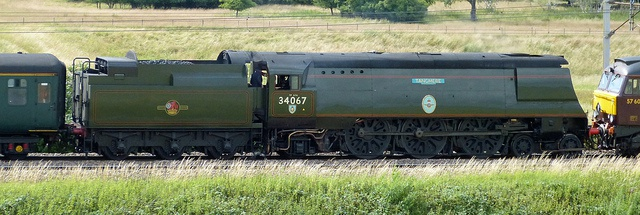Describe the objects in this image and their specific colors. I can see a train in tan, black, gray, purple, and darkgreen tones in this image. 